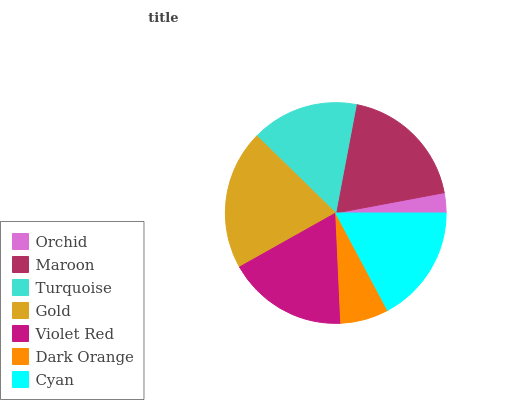Is Orchid the minimum?
Answer yes or no. Yes. Is Gold the maximum?
Answer yes or no. Yes. Is Maroon the minimum?
Answer yes or no. No. Is Maroon the maximum?
Answer yes or no. No. Is Maroon greater than Orchid?
Answer yes or no. Yes. Is Orchid less than Maroon?
Answer yes or no. Yes. Is Orchid greater than Maroon?
Answer yes or no. No. Is Maroon less than Orchid?
Answer yes or no. No. Is Cyan the high median?
Answer yes or no. Yes. Is Cyan the low median?
Answer yes or no. Yes. Is Violet Red the high median?
Answer yes or no. No. Is Maroon the low median?
Answer yes or no. No. 